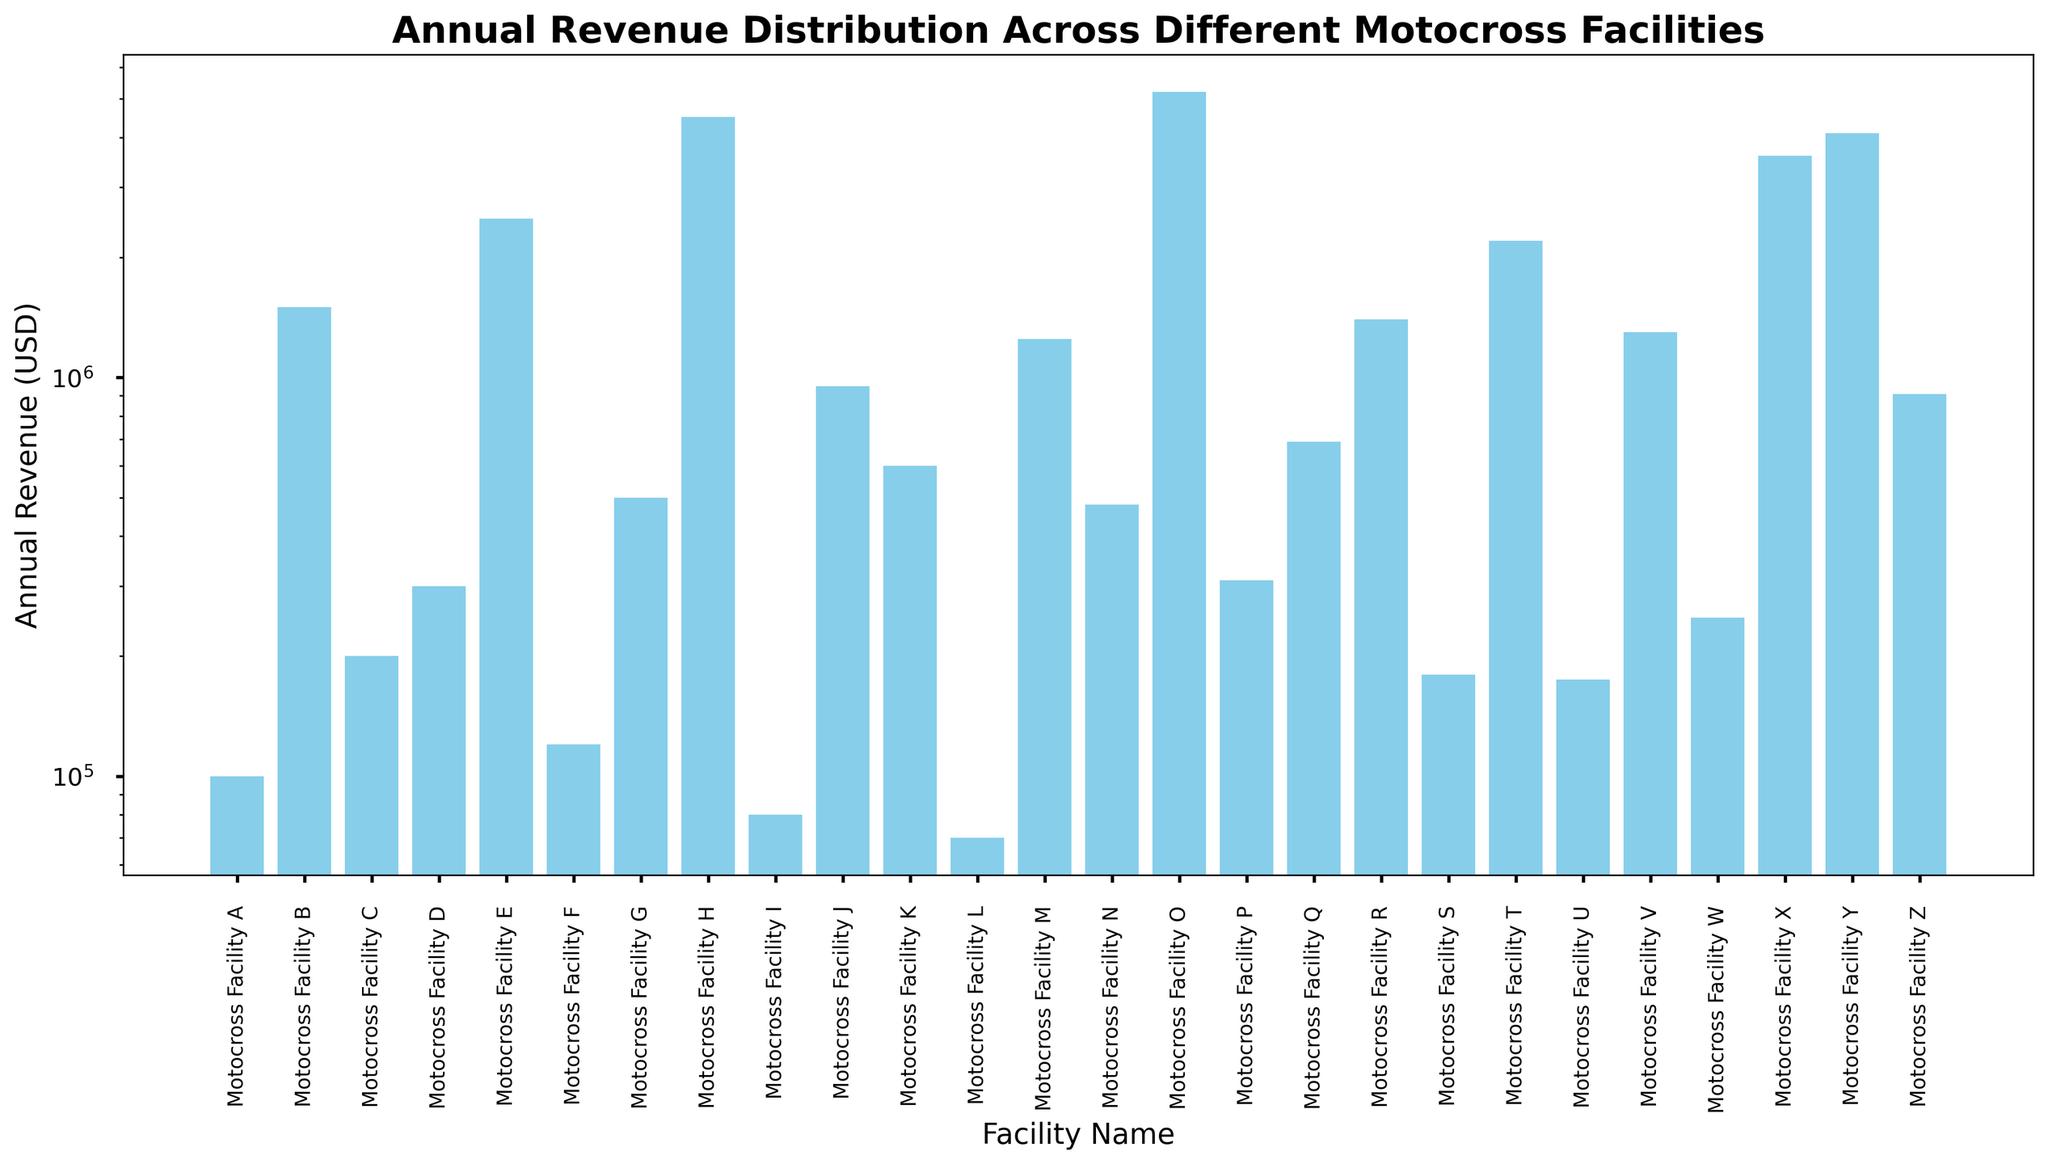Which facility has the lowest annual revenue? By examining the figure, we can identify the shortest bar. The shortest bar corresponds to Motocross Facility L.
Answer: Motocross Facility L What is the annual revenue difference between Motocross Facility H and Motocross Facility A? From the figure, Motocross Facility H has a revenue of $4,500,000 and Motocross Facility A has a revenue of $100,000. The difference is $4,500,000 - $100,000.
Answer: $4,400,000 Which facility generates more revenue, Motocross Facility M or Motocross Facility G? By comparing the heights of their respective bars, we see that Motocross Facility M has a taller bar than Motocross Facility G. Thus, Motocross Facility M generates more revenue than Motocross Facility G.
Answer: Motocross Facility M What is the median annual revenue of all the facilities? To find the median, arrange the revenues in ascending order and find the middle value. There are 26 facilities. The middle values are the 13th and 14th revenues. When sorted, they are $360,000 and $480,000; the median is the average of these two.
Answer: $420,000 Which facility has the closest annual revenue to $1,000,000? By visually scanning the bars on the plot and identifying the one nearest $1,000,000, we find Motocross Facility Z with $910,000.
Answer: Motocross Facility Z How many facilities have an annual revenue greater than $1,500,000? Count the number of bars that extend above the $1,500,000 mark on the log scale. Facilities B, H, E, O, T, X, and Y each exceed $1,500,000.
Answer: 7 Which facility has a higher annual revenue, Motocross Facility J or Motocross Facility V, and by how much? Comparing the heights, Facility V has an annual revenue of $1,300,000 while Facility J has $950,000. The difference is $1,300,000 - $950,000.
Answer: Motocross Facility V by $350,000 What is the average annual revenue of all facilities with revenues over $2,000,000? Identify facilities over $2,000,000: B, H, E, O, T, X, Y. Sum their revenues: $1,500,000 + $4,500,000 + $2,500,000 + $5,200,000 + $2,200,000 + $3,600,000 + $4,100,000. Then, divide by the number of such facilities (7).
Answer: $3,227,142.86 